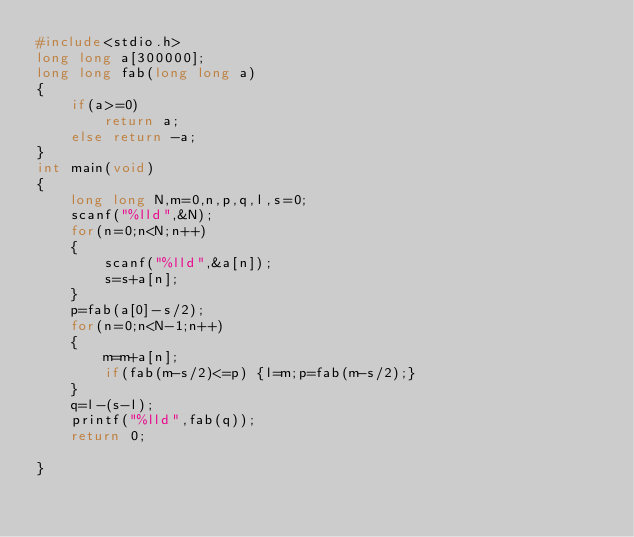Convert code to text. <code><loc_0><loc_0><loc_500><loc_500><_C_>#include<stdio.h>
long long a[300000];
long long fab(long long a)
{
    if(a>=0)
        return a;
    else return -a;
}
int main(void)
{
    long long N,m=0,n,p,q,l,s=0;
    scanf("%lld",&N);
    for(n=0;n<N;n++)
    {
        scanf("%lld",&a[n]);
        s=s+a[n];
    }
    p=fab(a[0]-s/2);
    for(n=0;n<N-1;n++)
    {
        m=m+a[n];
        if(fab(m-s/2)<=p) {l=m;p=fab(m-s/2);}
    }
    q=l-(s-l);
    printf("%lld",fab(q));
    return 0;

}</code> 